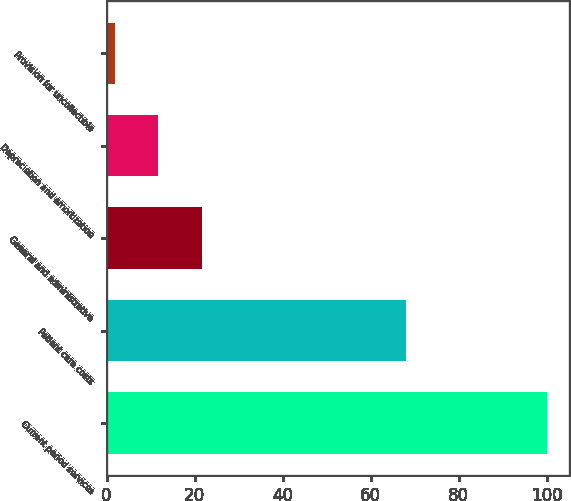Convert chart to OTSL. <chart><loc_0><loc_0><loc_500><loc_500><bar_chart><fcel>Current period services<fcel>Patient care costs<fcel>General and administrative<fcel>Depreciation and amortization<fcel>Provision for uncollectible<nl><fcel>100<fcel>68<fcel>21.6<fcel>11.8<fcel>2<nl></chart> 